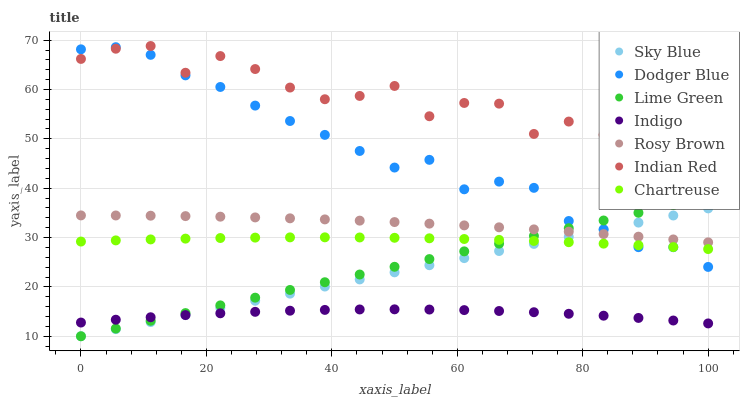Does Indigo have the minimum area under the curve?
Answer yes or no. Yes. Does Indian Red have the maximum area under the curve?
Answer yes or no. Yes. Does Rosy Brown have the minimum area under the curve?
Answer yes or no. No. Does Rosy Brown have the maximum area under the curve?
Answer yes or no. No. Is Sky Blue the smoothest?
Answer yes or no. Yes. Is Indian Red the roughest?
Answer yes or no. Yes. Is Rosy Brown the smoothest?
Answer yes or no. No. Is Rosy Brown the roughest?
Answer yes or no. No. Does Sky Blue have the lowest value?
Answer yes or no. Yes. Does Rosy Brown have the lowest value?
Answer yes or no. No. Does Indian Red have the highest value?
Answer yes or no. Yes. Does Rosy Brown have the highest value?
Answer yes or no. No. Is Chartreuse less than Indian Red?
Answer yes or no. Yes. Is Indian Red greater than Chartreuse?
Answer yes or no. Yes. Does Lime Green intersect Dodger Blue?
Answer yes or no. Yes. Is Lime Green less than Dodger Blue?
Answer yes or no. No. Is Lime Green greater than Dodger Blue?
Answer yes or no. No. Does Chartreuse intersect Indian Red?
Answer yes or no. No. 